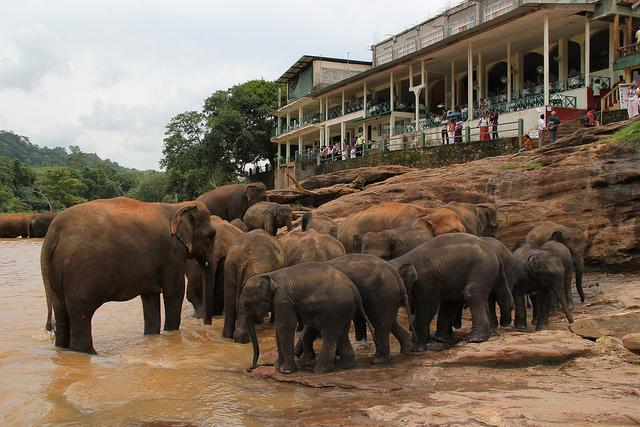What keeps the elephants out of the buildings? Please explain your reasoning. rocks. There is a visible rock barrier around the front of the buildings. a rock face this steep would not be possible for an elephant to climb. 